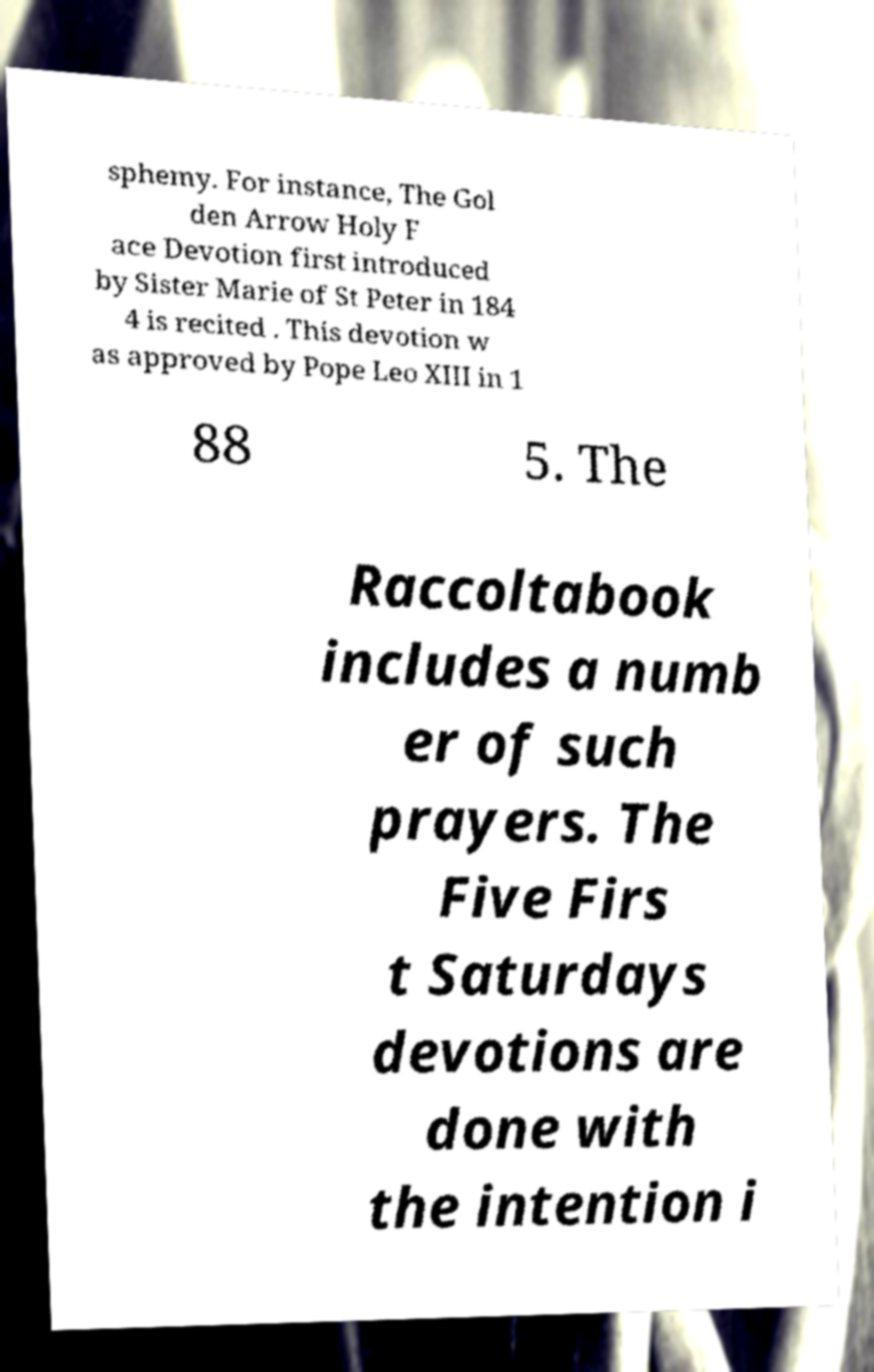Please read and relay the text visible in this image. What does it say? sphemy. For instance, The Gol den Arrow Holy F ace Devotion first introduced by Sister Marie of St Peter in 184 4 is recited . This devotion w as approved by Pope Leo XIII in 1 88 5. The Raccoltabook includes a numb er of such prayers. The Five Firs t Saturdays devotions are done with the intention i 